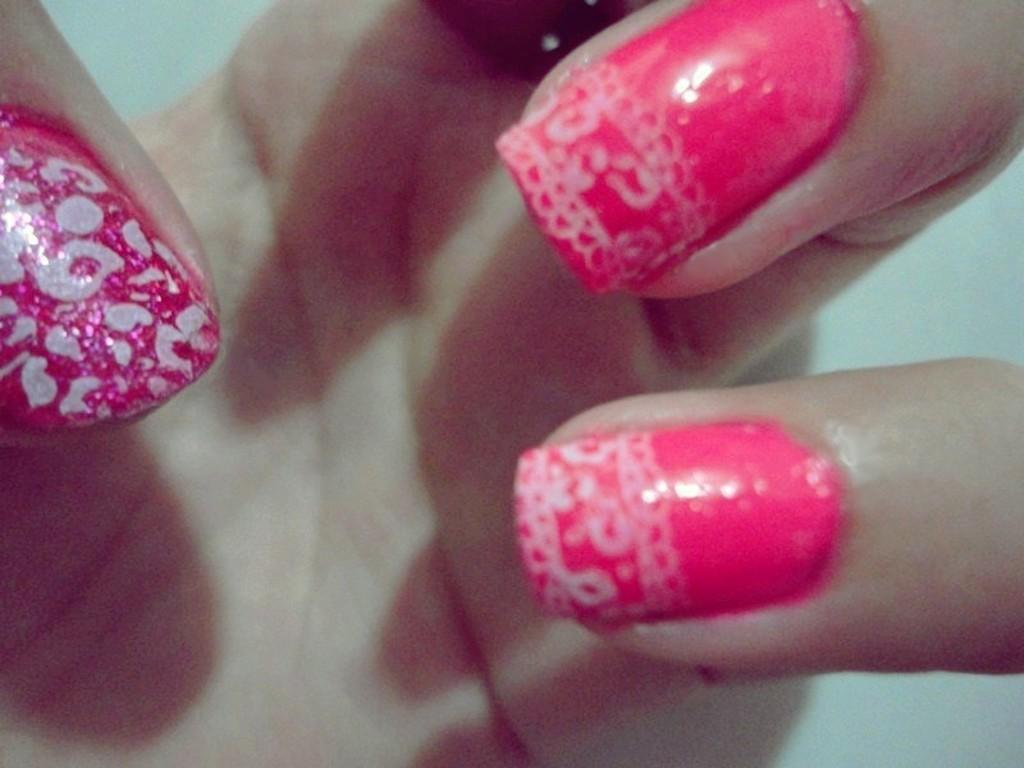What part of a person is visible in the image? There is a hand of a person in the image. What can be observed about the nails on the hand? The nails on the hand have pink nail paint. nail paint. Can you see a stream flowing near the hand in the image? There is no stream visible in the image; it only features a hand with pink nail paint. 